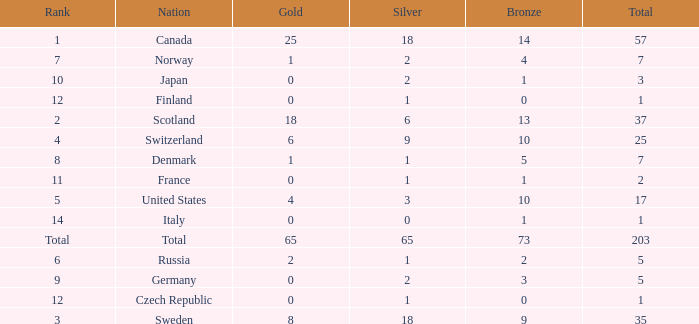What is the lowest total when the rank is 14 and the gold medals is larger than 0? None. 